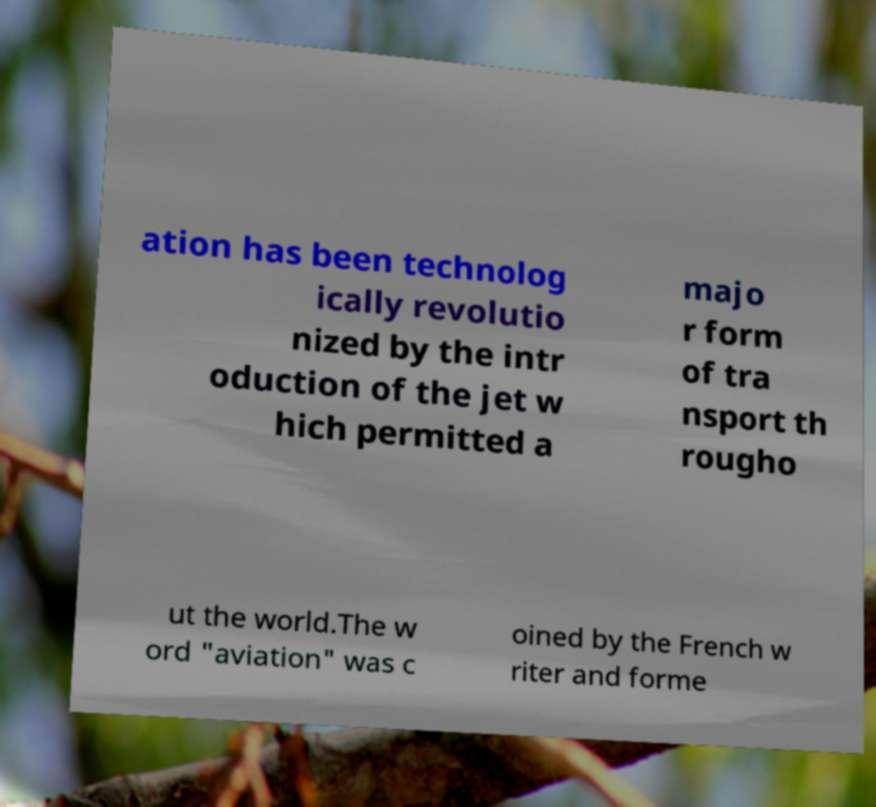There's text embedded in this image that I need extracted. Can you transcribe it verbatim? ation has been technolog ically revolutio nized by the intr oduction of the jet w hich permitted a majo r form of tra nsport th rougho ut the world.The w ord "aviation" was c oined by the French w riter and forme 